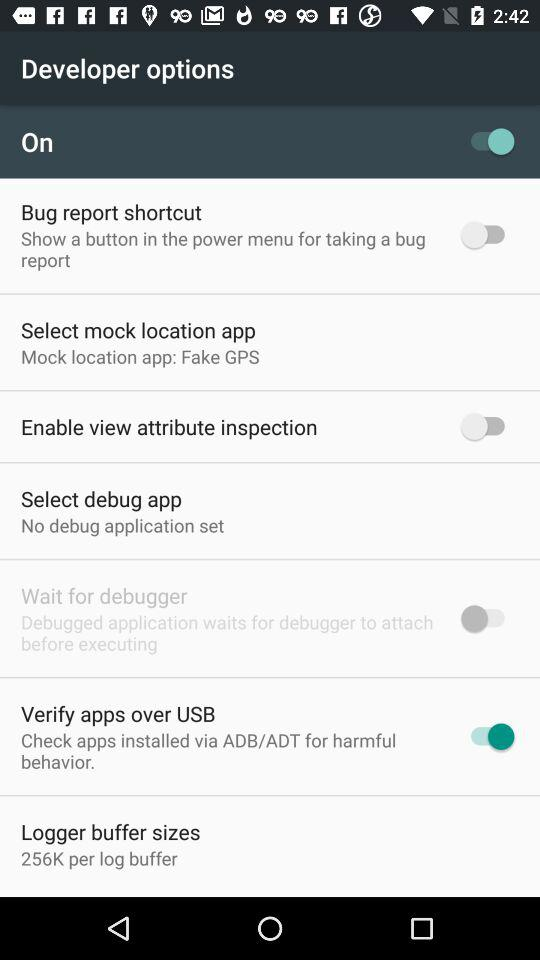What is the current status of "Verify apps over USB"? The current status is "on". 